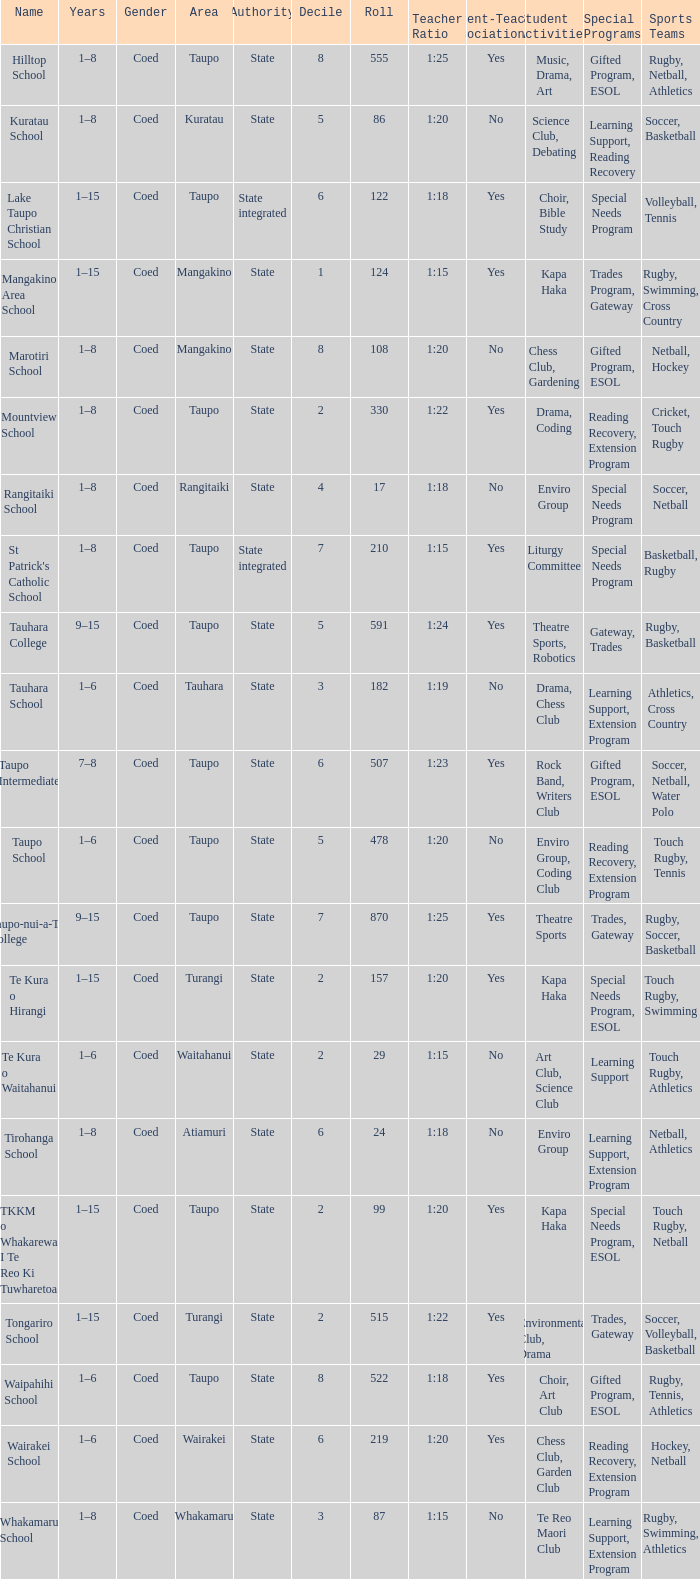What is the Whakamaru school's authority? State. 